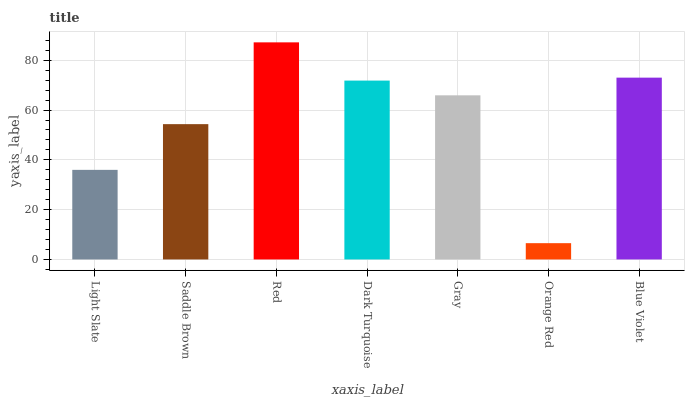Is Orange Red the minimum?
Answer yes or no. Yes. Is Red the maximum?
Answer yes or no. Yes. Is Saddle Brown the minimum?
Answer yes or no. No. Is Saddle Brown the maximum?
Answer yes or no. No. Is Saddle Brown greater than Light Slate?
Answer yes or no. Yes. Is Light Slate less than Saddle Brown?
Answer yes or no. Yes. Is Light Slate greater than Saddle Brown?
Answer yes or no. No. Is Saddle Brown less than Light Slate?
Answer yes or no. No. Is Gray the high median?
Answer yes or no. Yes. Is Gray the low median?
Answer yes or no. Yes. Is Blue Violet the high median?
Answer yes or no. No. Is Dark Turquoise the low median?
Answer yes or no. No. 